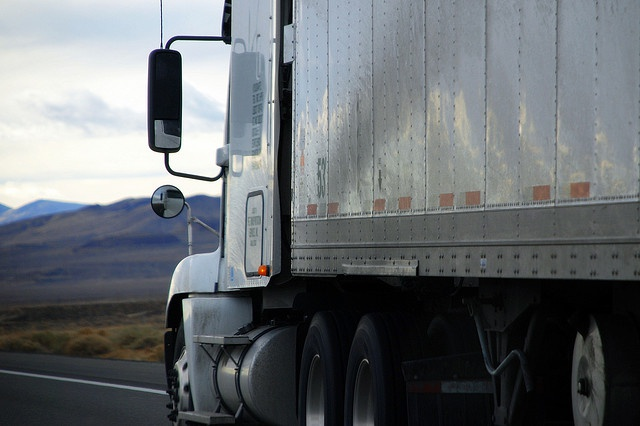Describe the objects in this image and their specific colors. I can see a truck in lightgray, black, darkgray, and gray tones in this image. 